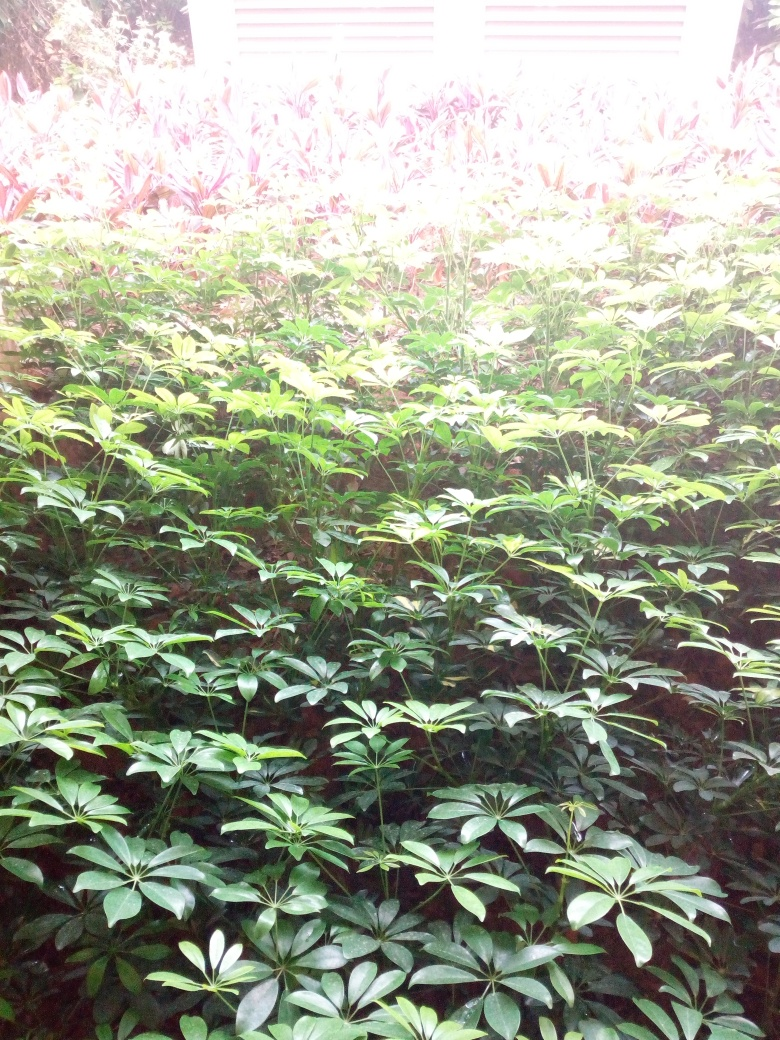What types of plants are visible in this image? The image features a variety of foliage, predominantly what appears to be Schefflera arboricola, commonly known as dwarf umbrella tree, characterized by its glossy, palmate leaves. There are also reddish plants in the back, which could be a species of the genus Cordyline, known for their striking color. 